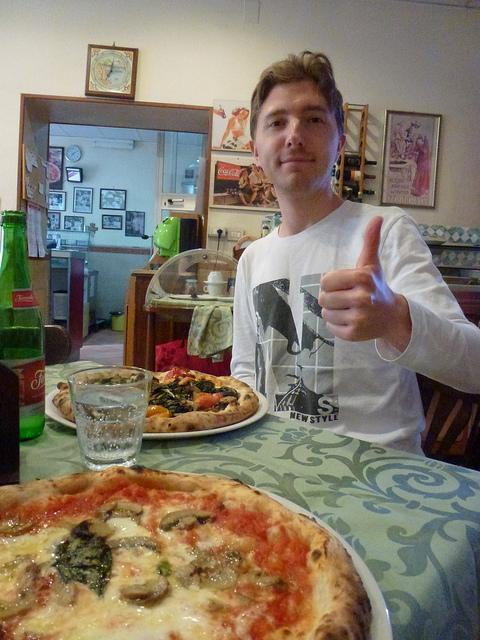Why is the man giving a thumbs up to the viewer? good food 